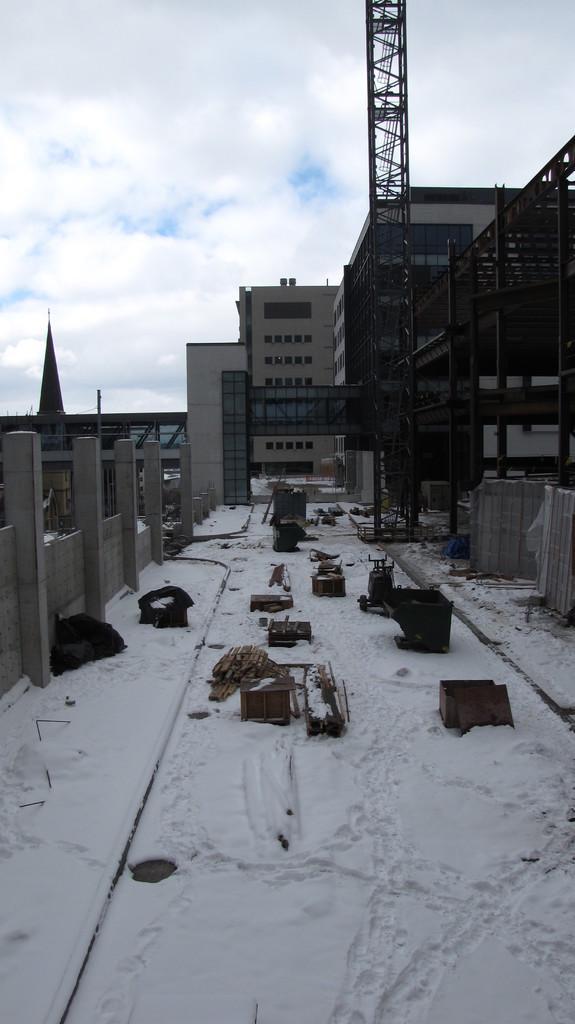How would you summarize this image in a sentence or two? In this picture there are buildings. In the foreground there is a tower and there are objects. At the top there is sky and there are clouds. At the bottom there is snow. 